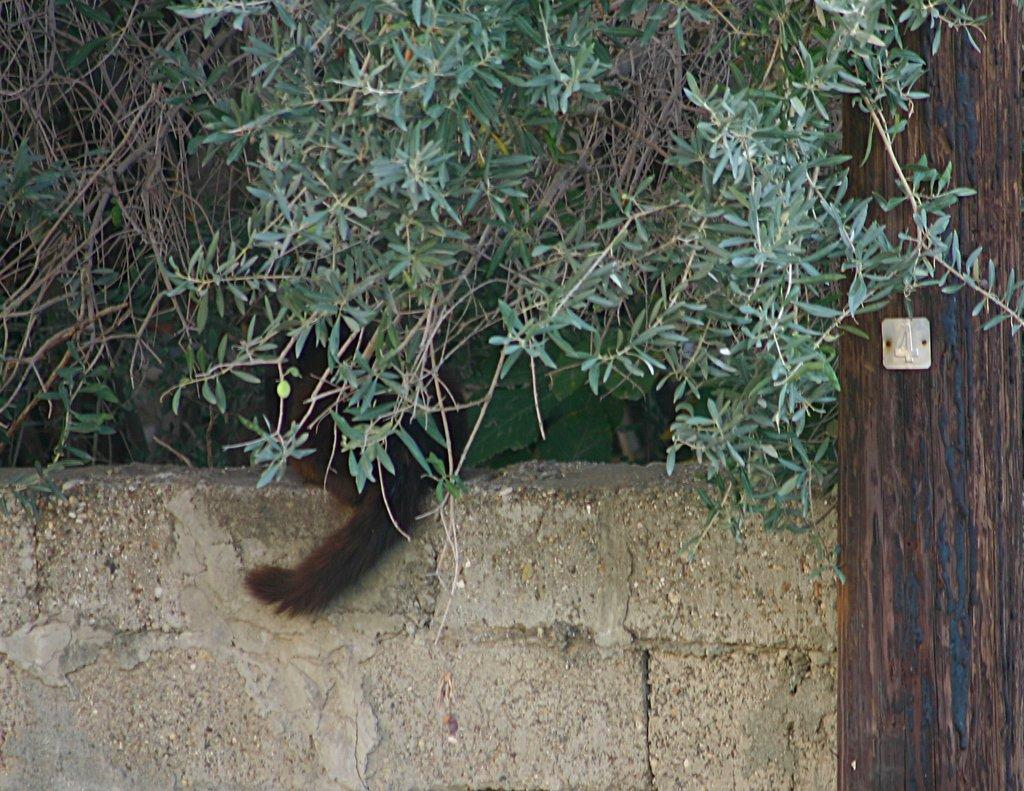What is present in the image that serves as a barrier or divider? There is a wall in the image. What can be seen in the distance behind the wall? There are trees in the background of the image. What is the color of the trees? The trees are green. What type of living creature is in the image? There is an animal in the image. What is the color of the animal? The animal is brown. Where is the animal located in the image? The animal is sitting on the wall. Can you see any waves in the image? There are no waves present in the image. Is there a chicken in the image? There is no chicken mentioned in the provided facts, so we cannot confirm its presence in the image. Where is the toothbrush in the image? There is no toothbrush mentioned in the provided facts, so we cannot confirm its presence in the image. 